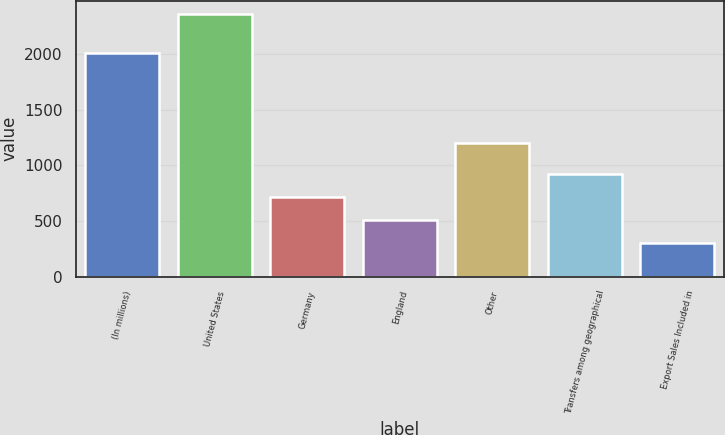Convert chart. <chart><loc_0><loc_0><loc_500><loc_500><bar_chart><fcel>(In millions)<fcel>United States<fcel>Germany<fcel>England<fcel>Other<fcel>Transfers among geographical<fcel>Export Sales Included in<nl><fcel>2006<fcel>2359<fcel>715.48<fcel>510.04<fcel>1201.5<fcel>920.92<fcel>304.6<nl></chart> 